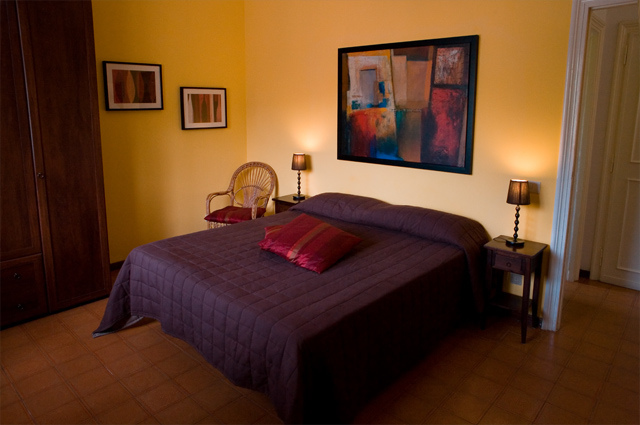<image>What type of light bulb is in these two lamps? I don't know. The light bulb in these two lamps could be yellow, energy saving, cfc, 60 watt, regular, night, led, low level, or small. What type of light bulb is in these two lamps? I don't know what type of light bulb is in these two lamps. It can be any of yellow, energy saving, cfc, 60 watt, regular, night, led, low level, or small. 